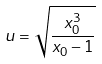<formula> <loc_0><loc_0><loc_500><loc_500>u = \sqrt { \frac { x _ { 0 } ^ { 3 } } { x _ { 0 } - 1 } }</formula> 